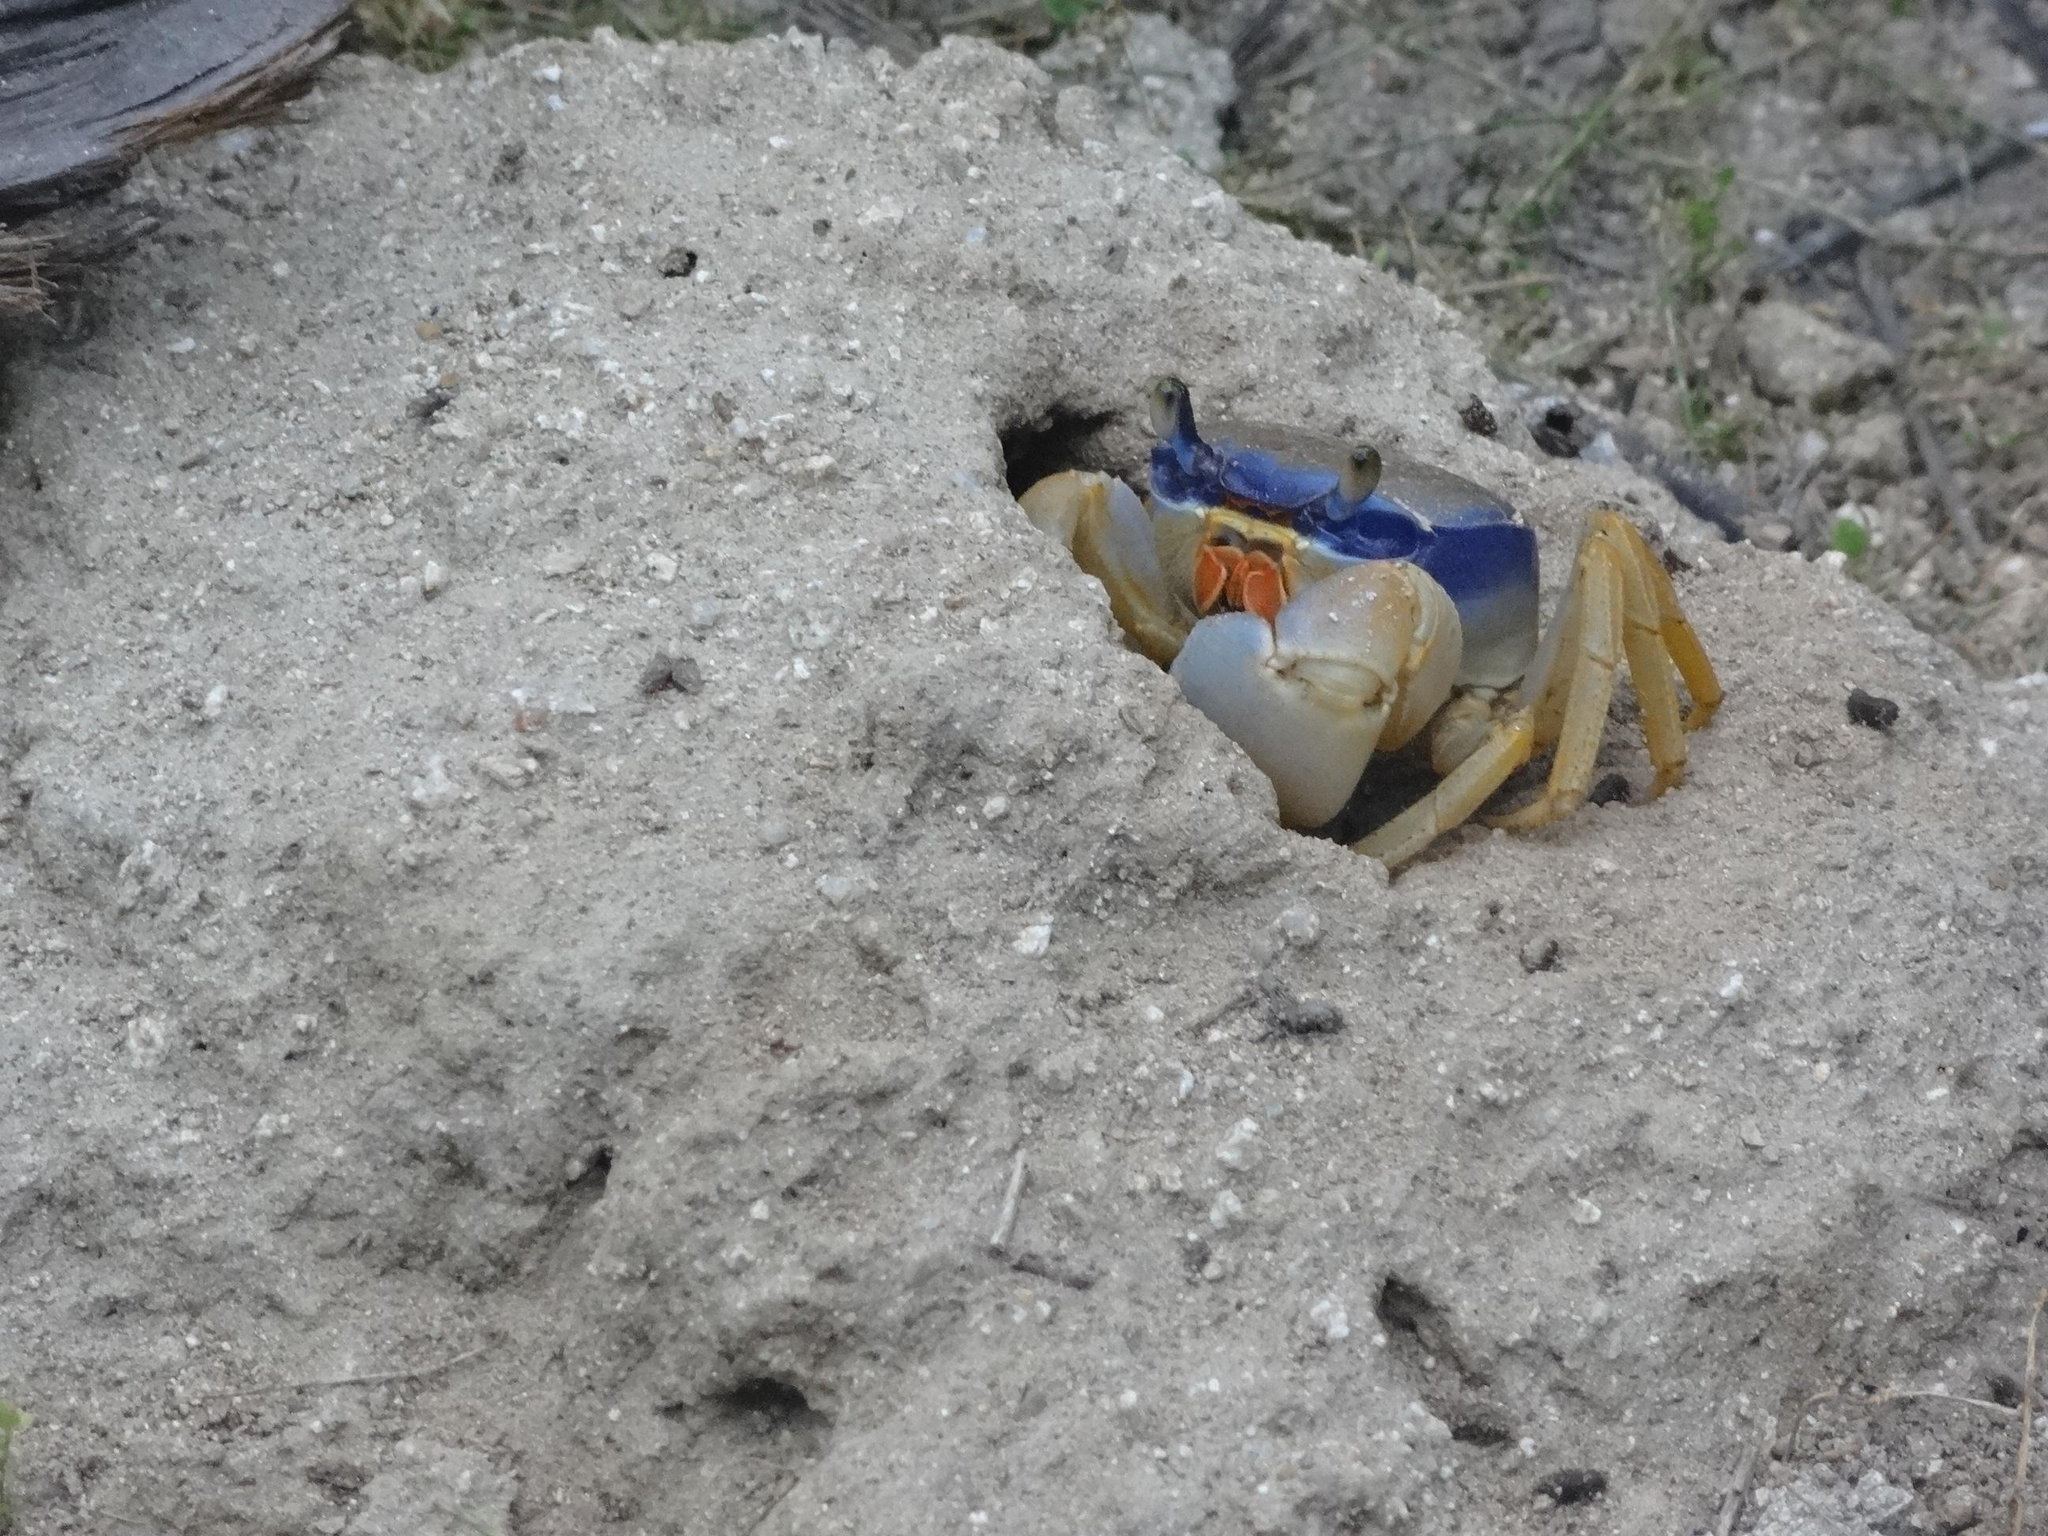What type of animal can be seen in the picture? There is a crab in the picture. What can be found on the ground in the picture? There are leaves on the ground in the picture. Where is the throne located in the picture? There is no throne present in the picture. What type of bomb can be seen in the picture? There is no bomb present in the picture. 